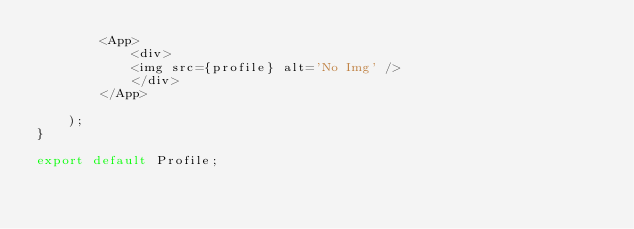Convert code to text. <code><loc_0><loc_0><loc_500><loc_500><_JavaScript_>        <App>
            <div>
            <img src={profile} alt='No Img' />
            </div>
        </App>

    );
}

export default Profile;</code> 